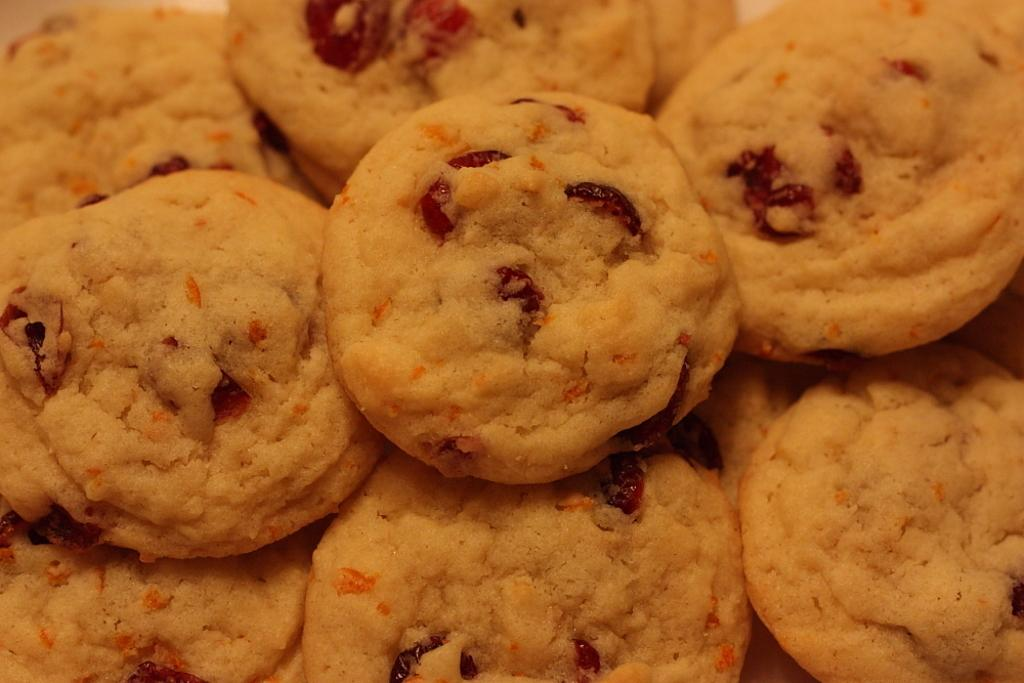What type of food is visible in the image? There is a group of cookies in the image. Can you describe the cookies in the image? The image shows a group of cookies, but it does not provide specific details about their appearance or flavor. Are there any other objects or food items visible in the image? The provided facts only mention the group of cookies, so there is no information about any other objects or food items in the image. How many pigs are sitting on the table in the image? There are no pigs or tables present in the image; it only features a group of cookies. 